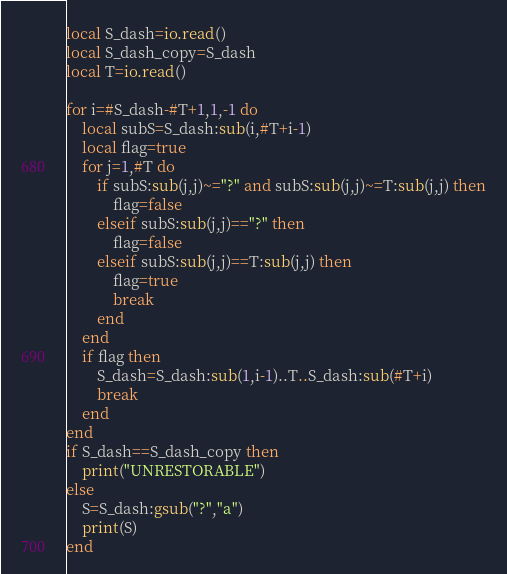Convert code to text. <code><loc_0><loc_0><loc_500><loc_500><_Lua_>local S_dash=io.read()
local S_dash_copy=S_dash
local T=io.read()

for i=#S_dash-#T+1,1,-1 do
    local subS=S_dash:sub(i,#T+i-1)
    local flag=true
    for j=1,#T do
        if subS:sub(j,j)~="?" and subS:sub(j,j)~=T:sub(j,j) then
            flag=false
        elseif subS:sub(j,j)=="?" then
            flag=false
        elseif subS:sub(j,j)==T:sub(j,j) then
            flag=true
            break
        end
    end
    if flag then
        S_dash=S_dash:sub(1,i-1)..T..S_dash:sub(#T+i)
        break
    end
end
if S_dash==S_dash_copy then
    print("UNRESTORABLE")
else
    S=S_dash:gsub("?","a")
    print(S)
end</code> 